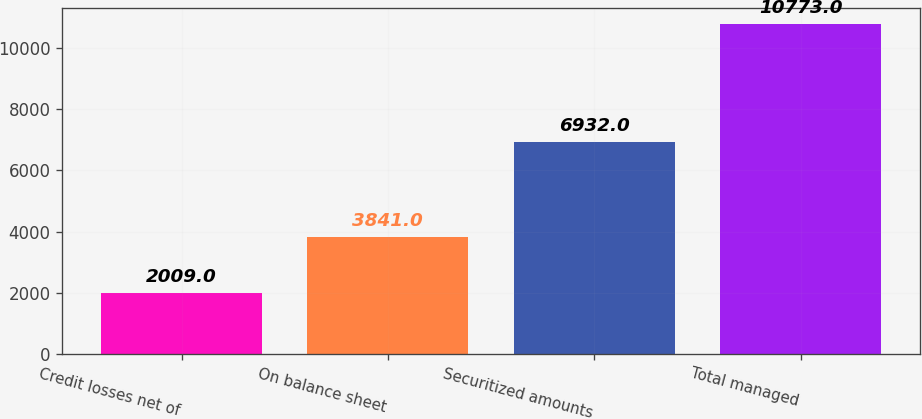Convert chart to OTSL. <chart><loc_0><loc_0><loc_500><loc_500><bar_chart><fcel>Credit losses net of<fcel>On balance sheet<fcel>Securitized amounts<fcel>Total managed<nl><fcel>2009<fcel>3841<fcel>6932<fcel>10773<nl></chart> 